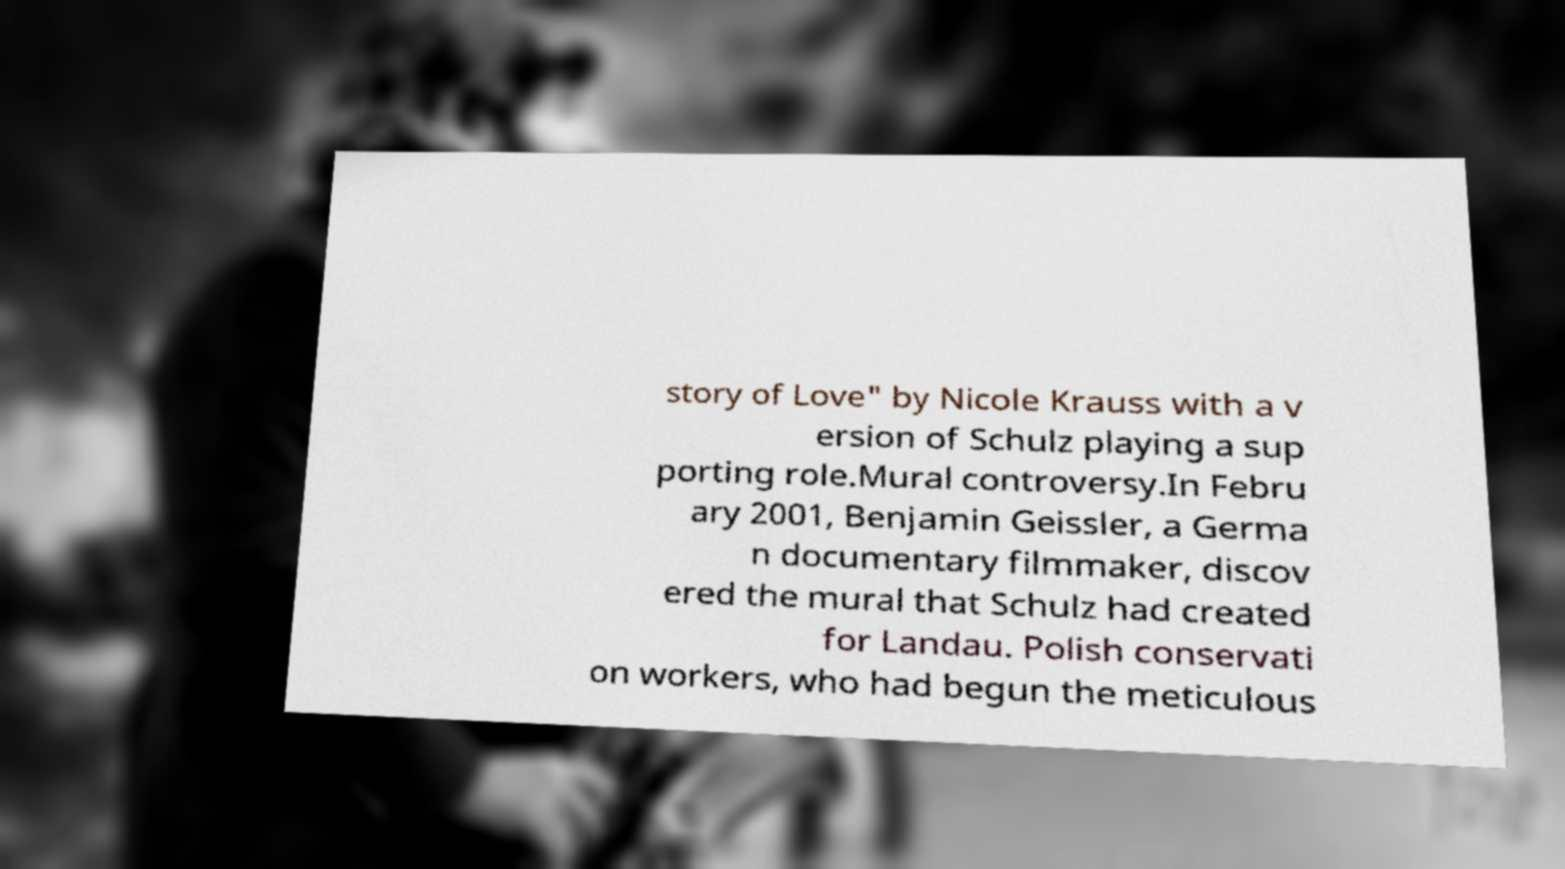For documentation purposes, I need the text within this image transcribed. Could you provide that? story of Love" by Nicole Krauss with a v ersion of Schulz playing a sup porting role.Mural controversy.In Febru ary 2001, Benjamin Geissler, a Germa n documentary filmmaker, discov ered the mural that Schulz had created for Landau. Polish conservati on workers, who had begun the meticulous 